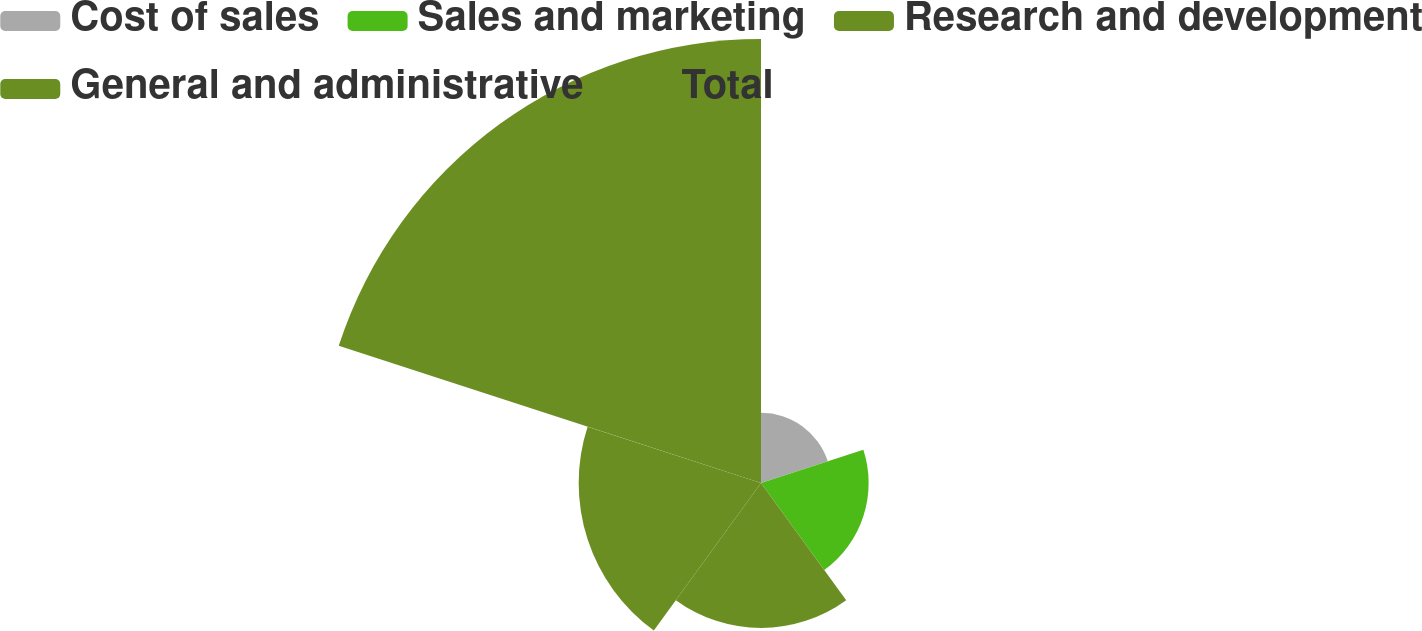Convert chart. <chart><loc_0><loc_0><loc_500><loc_500><pie_chart><fcel>Cost of sales<fcel>Sales and marketing<fcel>Research and development<fcel>General and administrative<fcel>Total<nl><fcel>7.4%<fcel>11.34%<fcel>15.27%<fcel>19.21%<fcel>46.78%<nl></chart> 